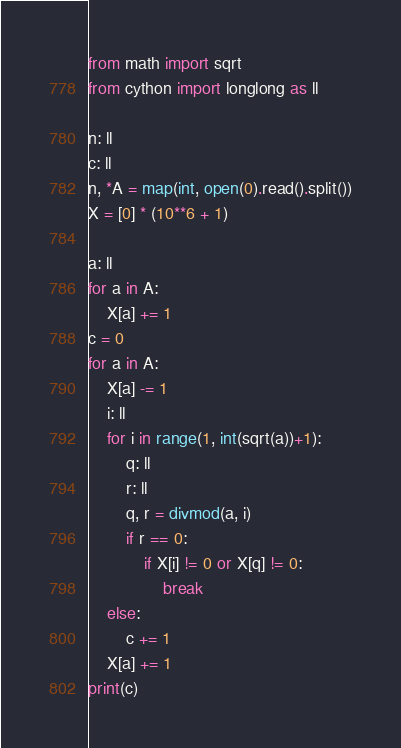<code> <loc_0><loc_0><loc_500><loc_500><_Cython_>from math import sqrt
from cython import longlong as ll

n: ll
c: ll
n, *A = map(int, open(0).read().split())
X = [0] * (10**6 + 1)

a: ll
for a in A:
    X[a] += 1
c = 0
for a in A:
    X[a] -= 1
    i: ll
    for i in range(1, int(sqrt(a))+1):
        q: ll
        r: ll
        q, r = divmod(a, i)
        if r == 0:
            if X[i] != 0 or X[q] != 0:
                break
    else:
        c += 1
    X[a] += 1
print(c)</code> 